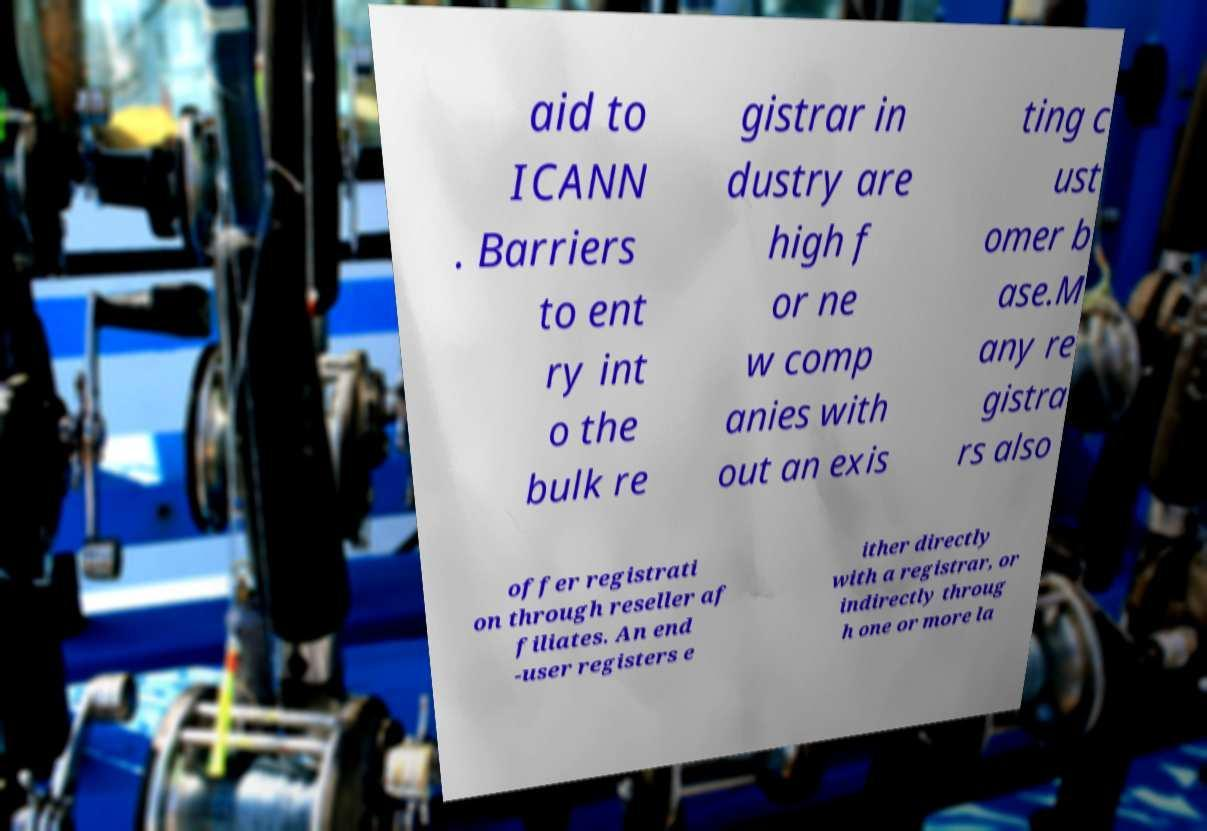Please identify and transcribe the text found in this image. aid to ICANN . Barriers to ent ry int o the bulk re gistrar in dustry are high f or ne w comp anies with out an exis ting c ust omer b ase.M any re gistra rs also offer registrati on through reseller af filiates. An end -user registers e ither directly with a registrar, or indirectly throug h one or more la 